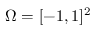<formula> <loc_0><loc_0><loc_500><loc_500>\Omega = [ - 1 , 1 ] ^ { 2 }</formula> 